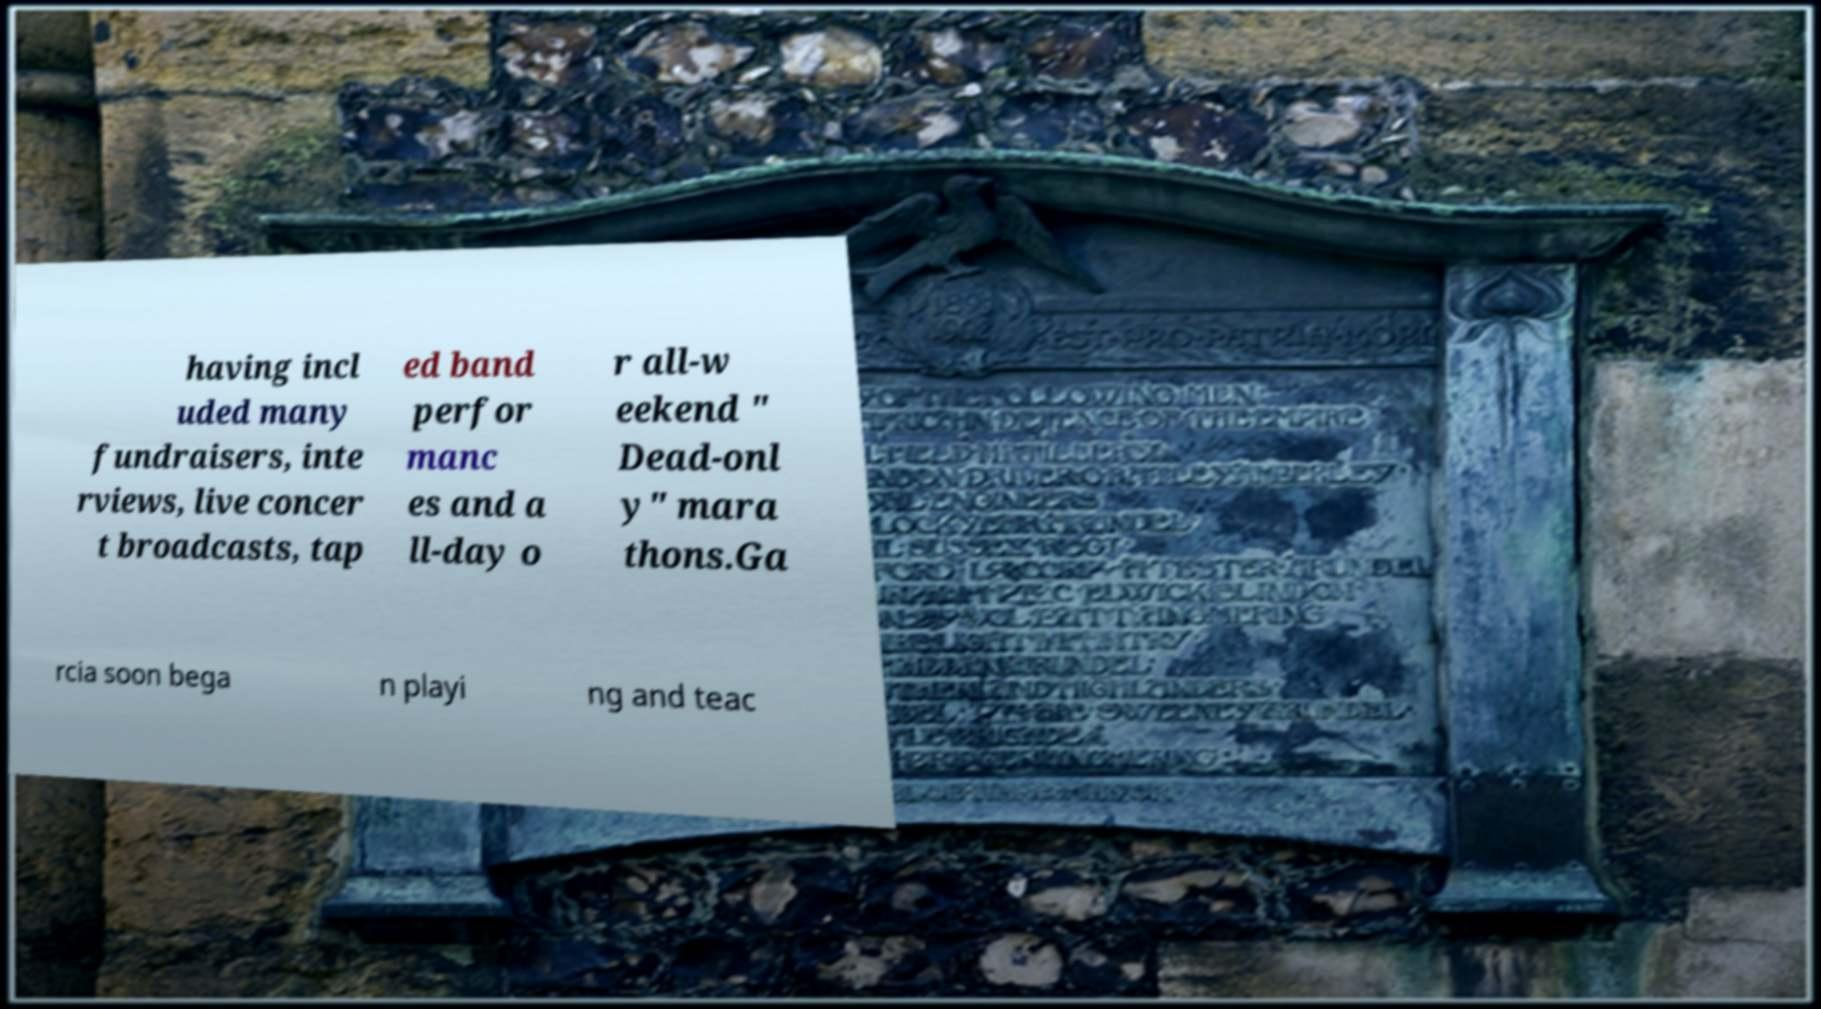Could you extract and type out the text from this image? having incl uded many fundraisers, inte rviews, live concer t broadcasts, tap ed band perfor manc es and a ll-day o r all-w eekend " Dead-onl y" mara thons.Ga rcia soon bega n playi ng and teac 